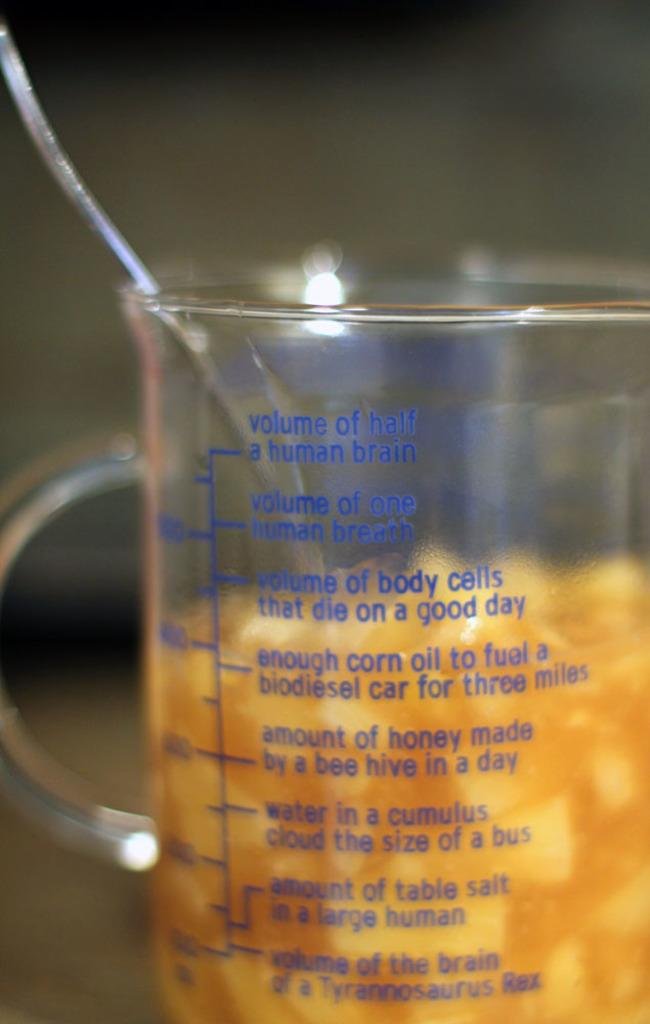Provide a one-sentence caption for the provided image. A spoon is in a measuring cup and is filled to the words volume of body cells that die on a good day. 